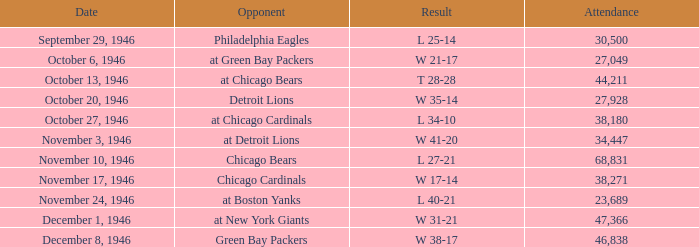What is the combined attendance of all games that had a result of w 35-14? 27928.0. 